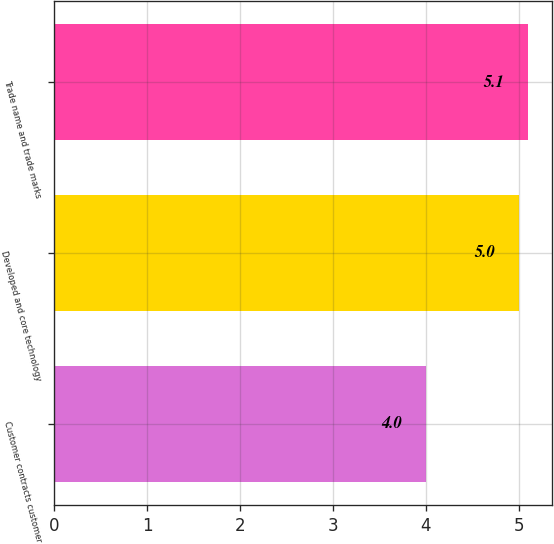<chart> <loc_0><loc_0><loc_500><loc_500><bar_chart><fcel>Customer contracts customer<fcel>Developed and core technology<fcel>Trade name and trade marks<nl><fcel>4<fcel>5<fcel>5.1<nl></chart> 